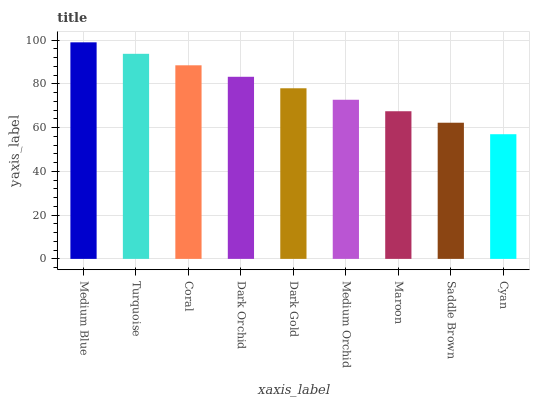Is Cyan the minimum?
Answer yes or no. Yes. Is Medium Blue the maximum?
Answer yes or no. Yes. Is Turquoise the minimum?
Answer yes or no. No. Is Turquoise the maximum?
Answer yes or no. No. Is Medium Blue greater than Turquoise?
Answer yes or no. Yes. Is Turquoise less than Medium Blue?
Answer yes or no. Yes. Is Turquoise greater than Medium Blue?
Answer yes or no. No. Is Medium Blue less than Turquoise?
Answer yes or no. No. Is Dark Gold the high median?
Answer yes or no. Yes. Is Dark Gold the low median?
Answer yes or no. Yes. Is Turquoise the high median?
Answer yes or no. No. Is Medium Blue the low median?
Answer yes or no. No. 